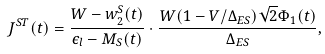<formula> <loc_0><loc_0><loc_500><loc_500>J ^ { S T } ( t ) = \frac { W - w _ { 2 } ^ { S } ( t ) } { \epsilon _ { l } - M _ { S } ( t ) } \cdot \frac { W ( 1 - V / \Delta _ { E S } ) \sqrt { 2 } \Phi _ { 1 } ( t ) } { \Delta _ { E S } } ,</formula> 